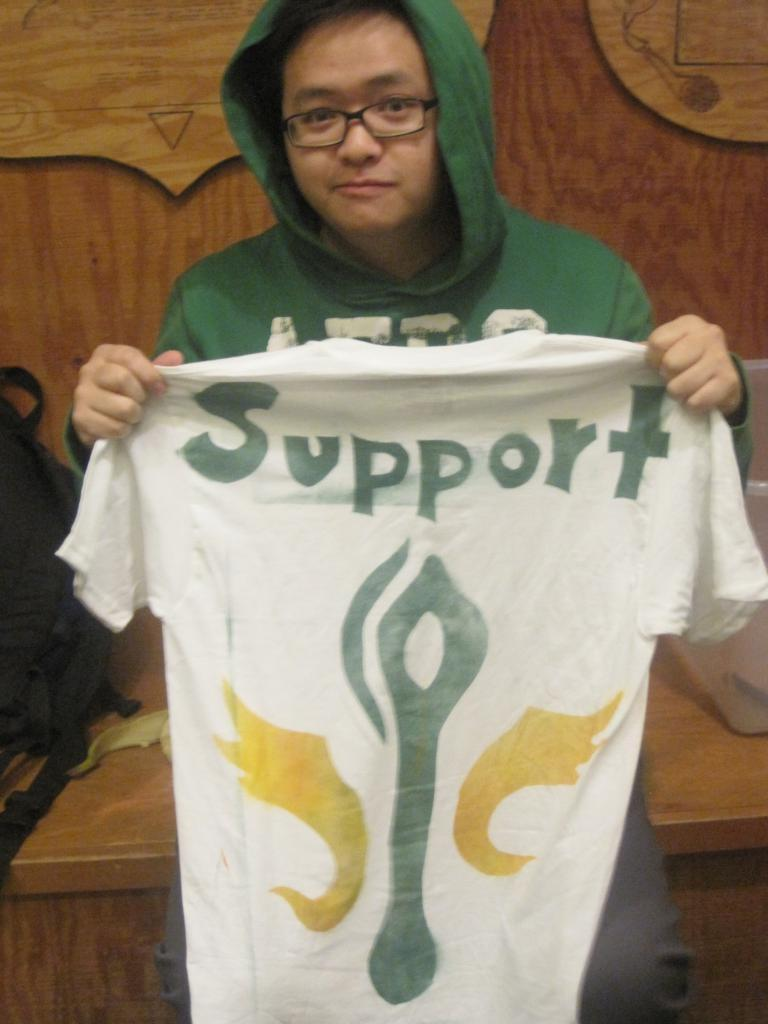What is the main subject of the image? There is a person in the image. What is the person wearing? The person is wearing a green dress. What is the person doing in the image? The person is sitting. What is the person holding? The person is holding a white T-shirt. What is written on the T-shirt? "Support" is written on the T-shirt. Where is the bag located in the image? The bag is in the left corner of the image. How many cows can be seen in the room in the image? There are no cows or rooms present in the image; it features a person sitting and holding a white T-shirt. 